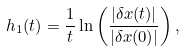<formula> <loc_0><loc_0><loc_500><loc_500>h _ { 1 } ( t ) = \frac { 1 } { t } \ln \left ( \frac { | \delta x ( t ) | } { | \delta x ( 0 ) | } \right ) ,</formula> 